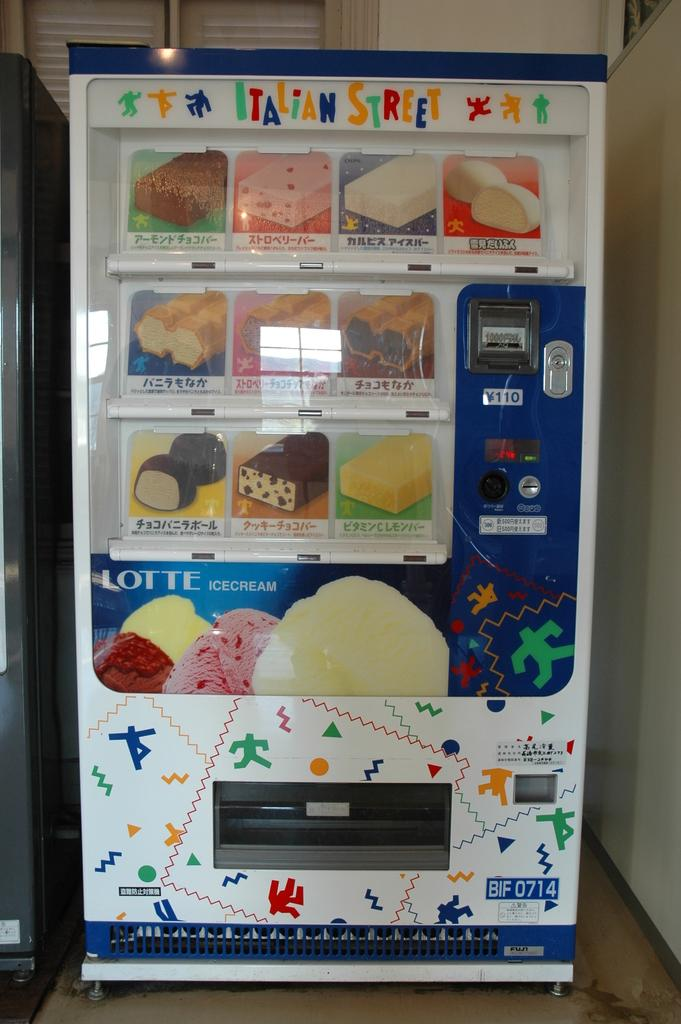What type of object is depicted in the image? The object is a vending machine. Can you describe the color combination of the vending machine? The vending machine has a white and blue color combination. What is the father doing with the vending machine in the image? There is no father present in the image, and the vending machine is stationary. Can you tell me how many flies are buzzing around the vending machine in the image? There are no flies present in the image. 